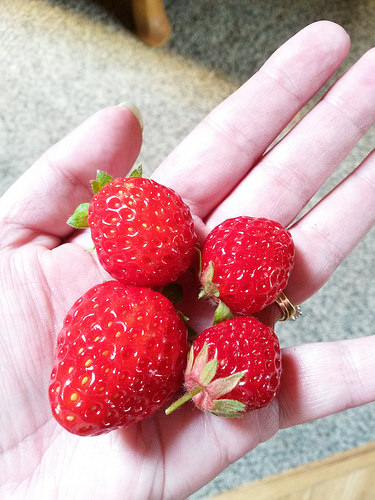<image>
Is there a strawberries on the floor? No. The strawberries is not positioned on the floor. They may be near each other, but the strawberries is not supported by or resting on top of the floor. Is there a nail under the strawberry? No. The nail is not positioned under the strawberry. The vertical relationship between these objects is different. 